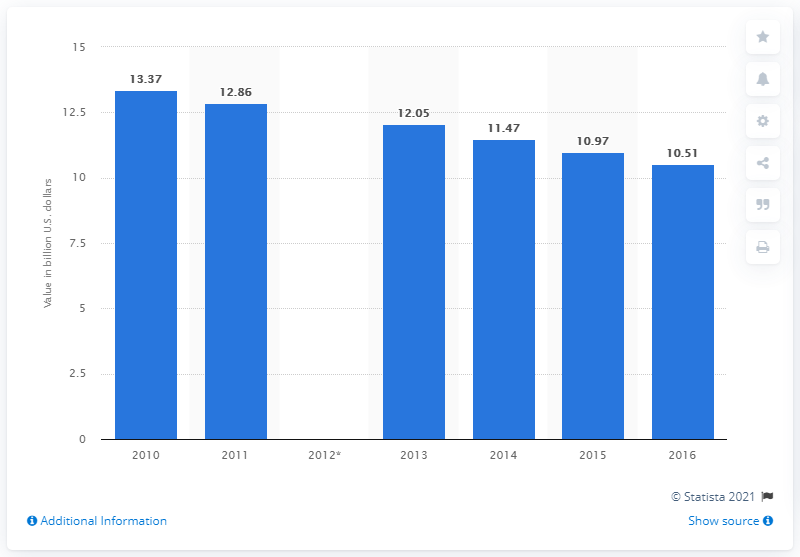Identify some key points in this picture. In 2017, the value of apparel product shipments in the United States was approximately 10.51 billion U.S. dollars. 